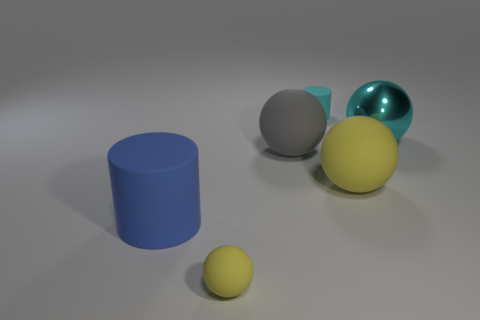Subtract all gray matte balls. How many balls are left? 3 Add 3 large cyan spheres. How many objects exist? 9 Subtract 1 cylinders. How many cylinders are left? 1 Subtract all cyan cylinders. How many cylinders are left? 1 Subtract all spheres. How many objects are left? 2 Subtract all green balls. Subtract all gray cubes. How many balls are left? 4 Subtract all purple cylinders. How many blue spheres are left? 0 Subtract all small matte spheres. Subtract all metal balls. How many objects are left? 4 Add 1 blue rubber cylinders. How many blue rubber cylinders are left? 2 Add 2 large gray rubber objects. How many large gray rubber objects exist? 3 